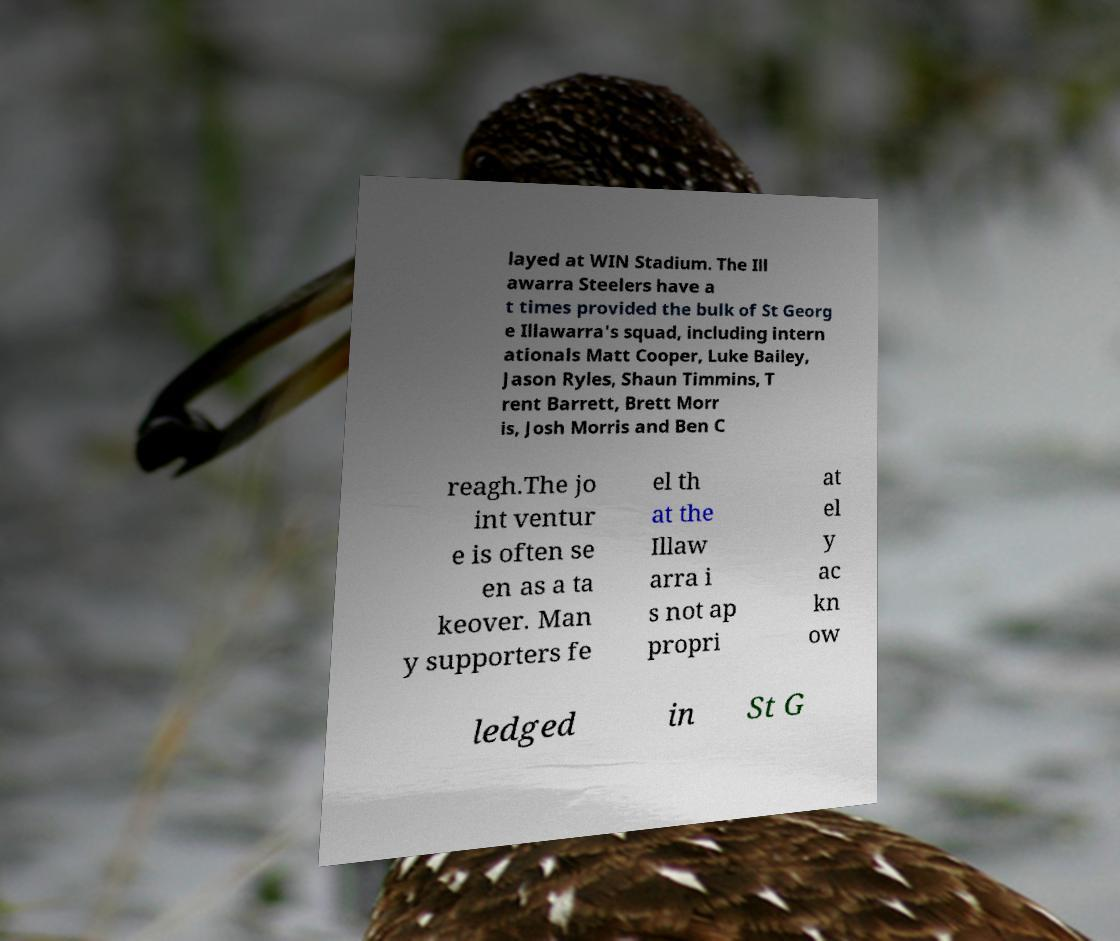I need the written content from this picture converted into text. Can you do that? layed at WIN Stadium. The Ill awarra Steelers have a t times provided the bulk of St Georg e Illawarra's squad, including intern ationals Matt Cooper, Luke Bailey, Jason Ryles, Shaun Timmins, T rent Barrett, Brett Morr is, Josh Morris and Ben C reagh.The jo int ventur e is often se en as a ta keover. Man y supporters fe el th at the Illaw arra i s not ap propri at el y ac kn ow ledged in St G 